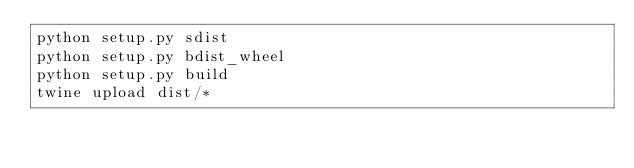<code> <loc_0><loc_0><loc_500><loc_500><_Bash_>python setup.py sdist
python setup.py bdist_wheel
python setup.py build
twine upload dist/*</code> 